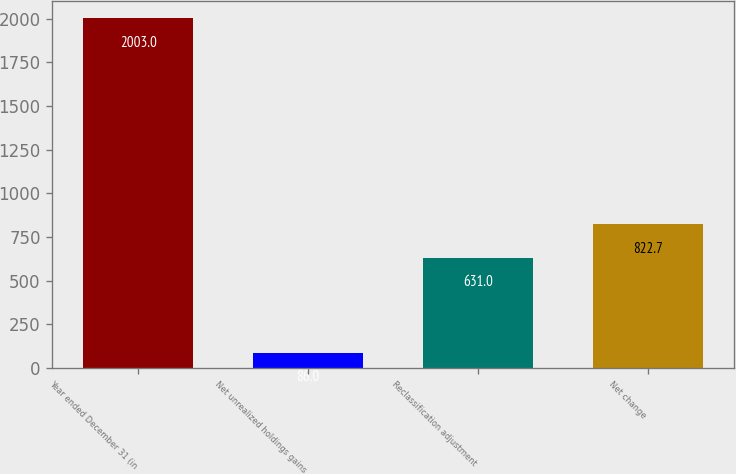Convert chart to OTSL. <chart><loc_0><loc_0><loc_500><loc_500><bar_chart><fcel>Year ended December 31 (in<fcel>Net unrealized holdings gains<fcel>Reclassification adjustment<fcel>Net change<nl><fcel>2003<fcel>86<fcel>631<fcel>822.7<nl></chart> 